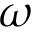<formula> <loc_0><loc_0><loc_500><loc_500>\omega</formula> 